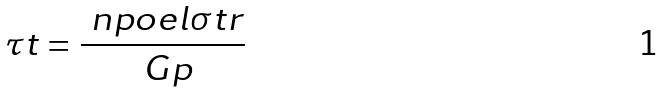Convert formula to latex. <formula><loc_0><loc_0><loc_500><loc_500>\tau t = \frac { \ n p o e l \sigma t r } { \ G p }</formula> 